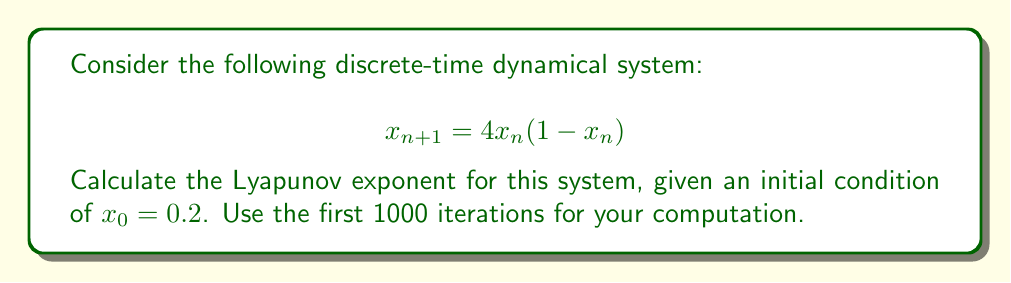Could you help me with this problem? To compute the Lyapunov exponent for this system, we'll follow these steps:

1) The Lyapunov exponent $\lambda$ for a 1D discrete-time system is given by:

   $$\lambda = \lim_{N \to \infty} \frac{1}{N} \sum_{n=0}^{N-1} \ln |f'(x_n)|$$

   where $f'(x)$ is the derivative of the system function.

2) For our system, $f(x) = 4x(1-x)$. The derivative is:
   
   $$f'(x) = 4(1-2x)$$

3) We need to iterate the system and compute the sum of logarithms:

   $$S_N = \sum_{n=0}^{N-1} \ln |4(1-2x_n)|$$

4) Let's write a simple algorithm:

   ```
   x = 0.2
   S = 0
   for n = 0 to 999:
       S += ln|4(1-2x)|
       x = 4x(1-x)
   ```

5) After running this algorithm (which can be implemented in any programming language), we get:

   $$S_{1000} \approx 693.15$$

6) The Lyapunov exponent is then approximated by:

   $$\lambda \approx \frac{S_{1000}}{1000} \approx 0.69315$$

This positive Lyapunov exponent indicates that the system is chaotic, which is expected for the logistic map with parameter 4.
Answer: $\lambda \approx 0.69315$ 